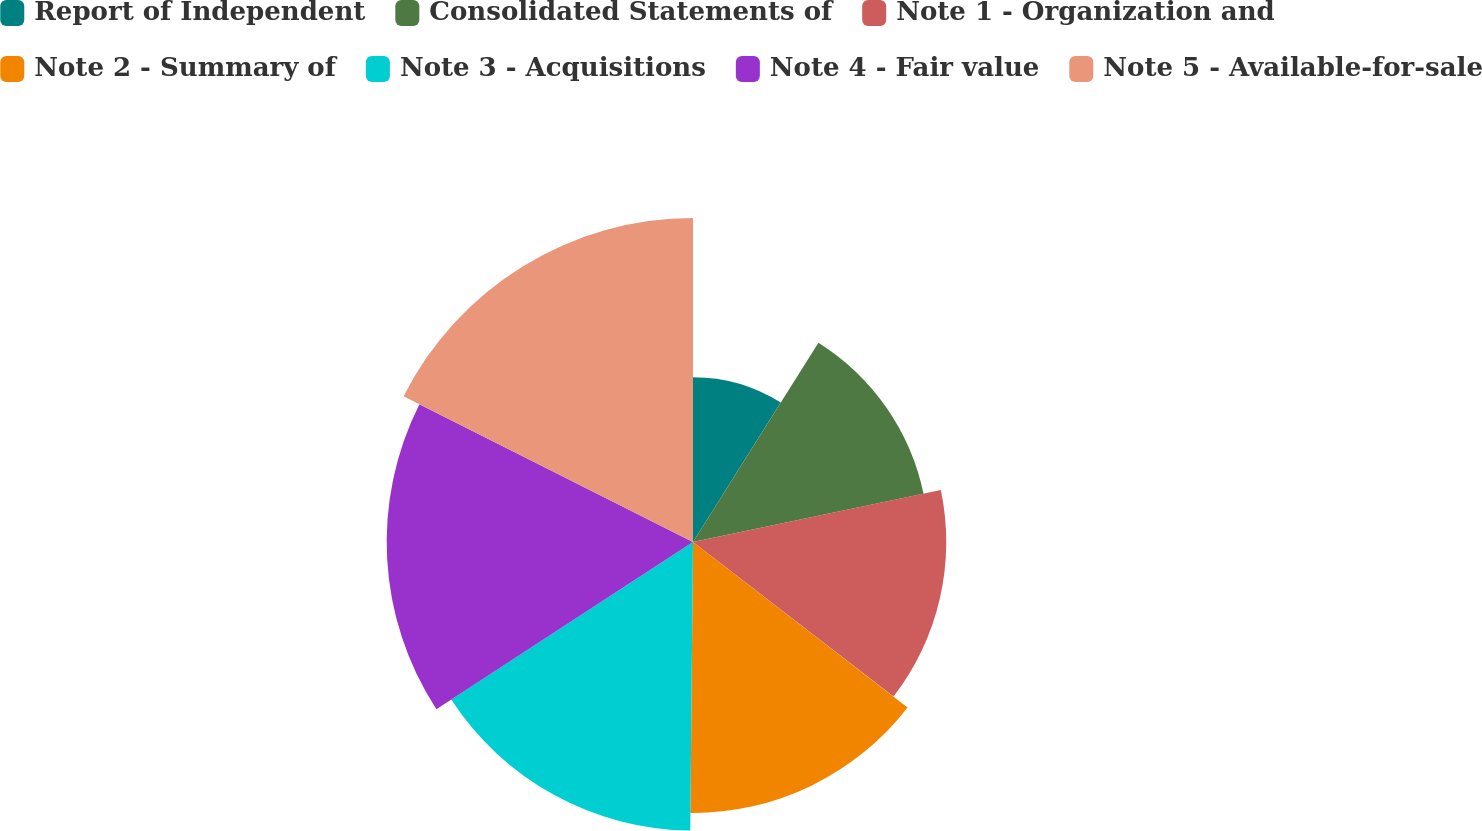Convert chart. <chart><loc_0><loc_0><loc_500><loc_500><pie_chart><fcel>Report of Independent<fcel>Consolidated Statements of<fcel>Note 1 - Organization and<fcel>Note 2 - Summary of<fcel>Note 3 - Acquisitions<fcel>Note 4 - Fair value<fcel>Note 5 - Available-for-sale<nl><fcel>8.94%<fcel>12.78%<fcel>13.74%<fcel>14.7%<fcel>15.66%<fcel>16.62%<fcel>17.58%<nl></chart> 